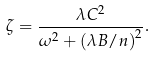Convert formula to latex. <formula><loc_0><loc_0><loc_500><loc_500>\zeta = \frac { \lambda C ^ { 2 } } { \omega ^ { 2 } + \left ( \lambda B / n \right ) ^ { 2 } } .</formula> 